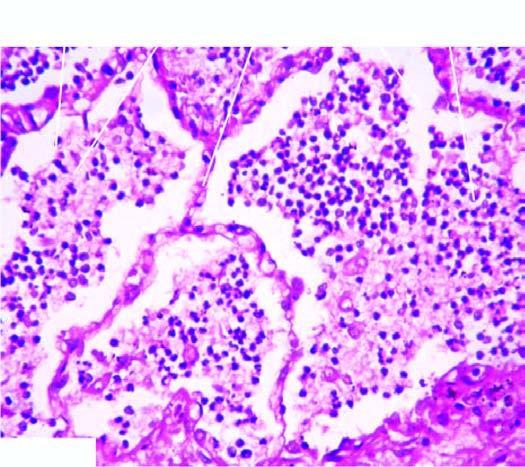does one marrow show grey-brown, firm area of consolidation affecting a lobe?
Answer the question using a single word or phrase. No 